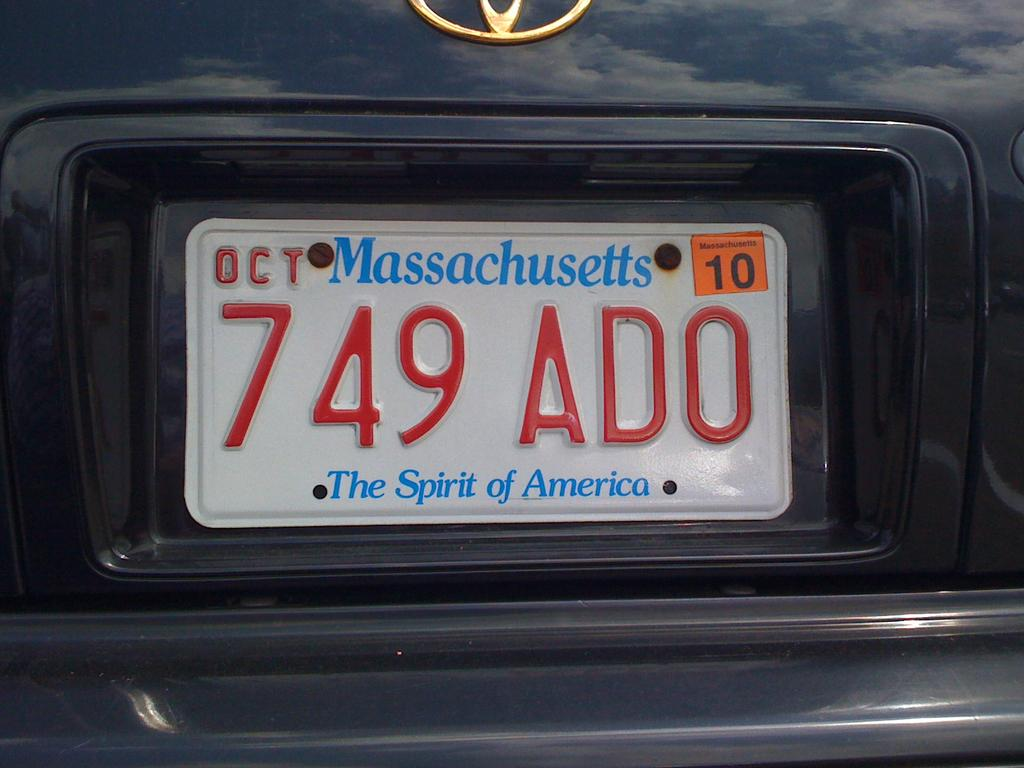<image>
Describe the image concisely. massachusetts car with license plates that reads 749ado 